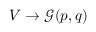<formula> <loc_0><loc_0><loc_500><loc_500>V \to { \mathcal { G } } ( p , q )</formula> 